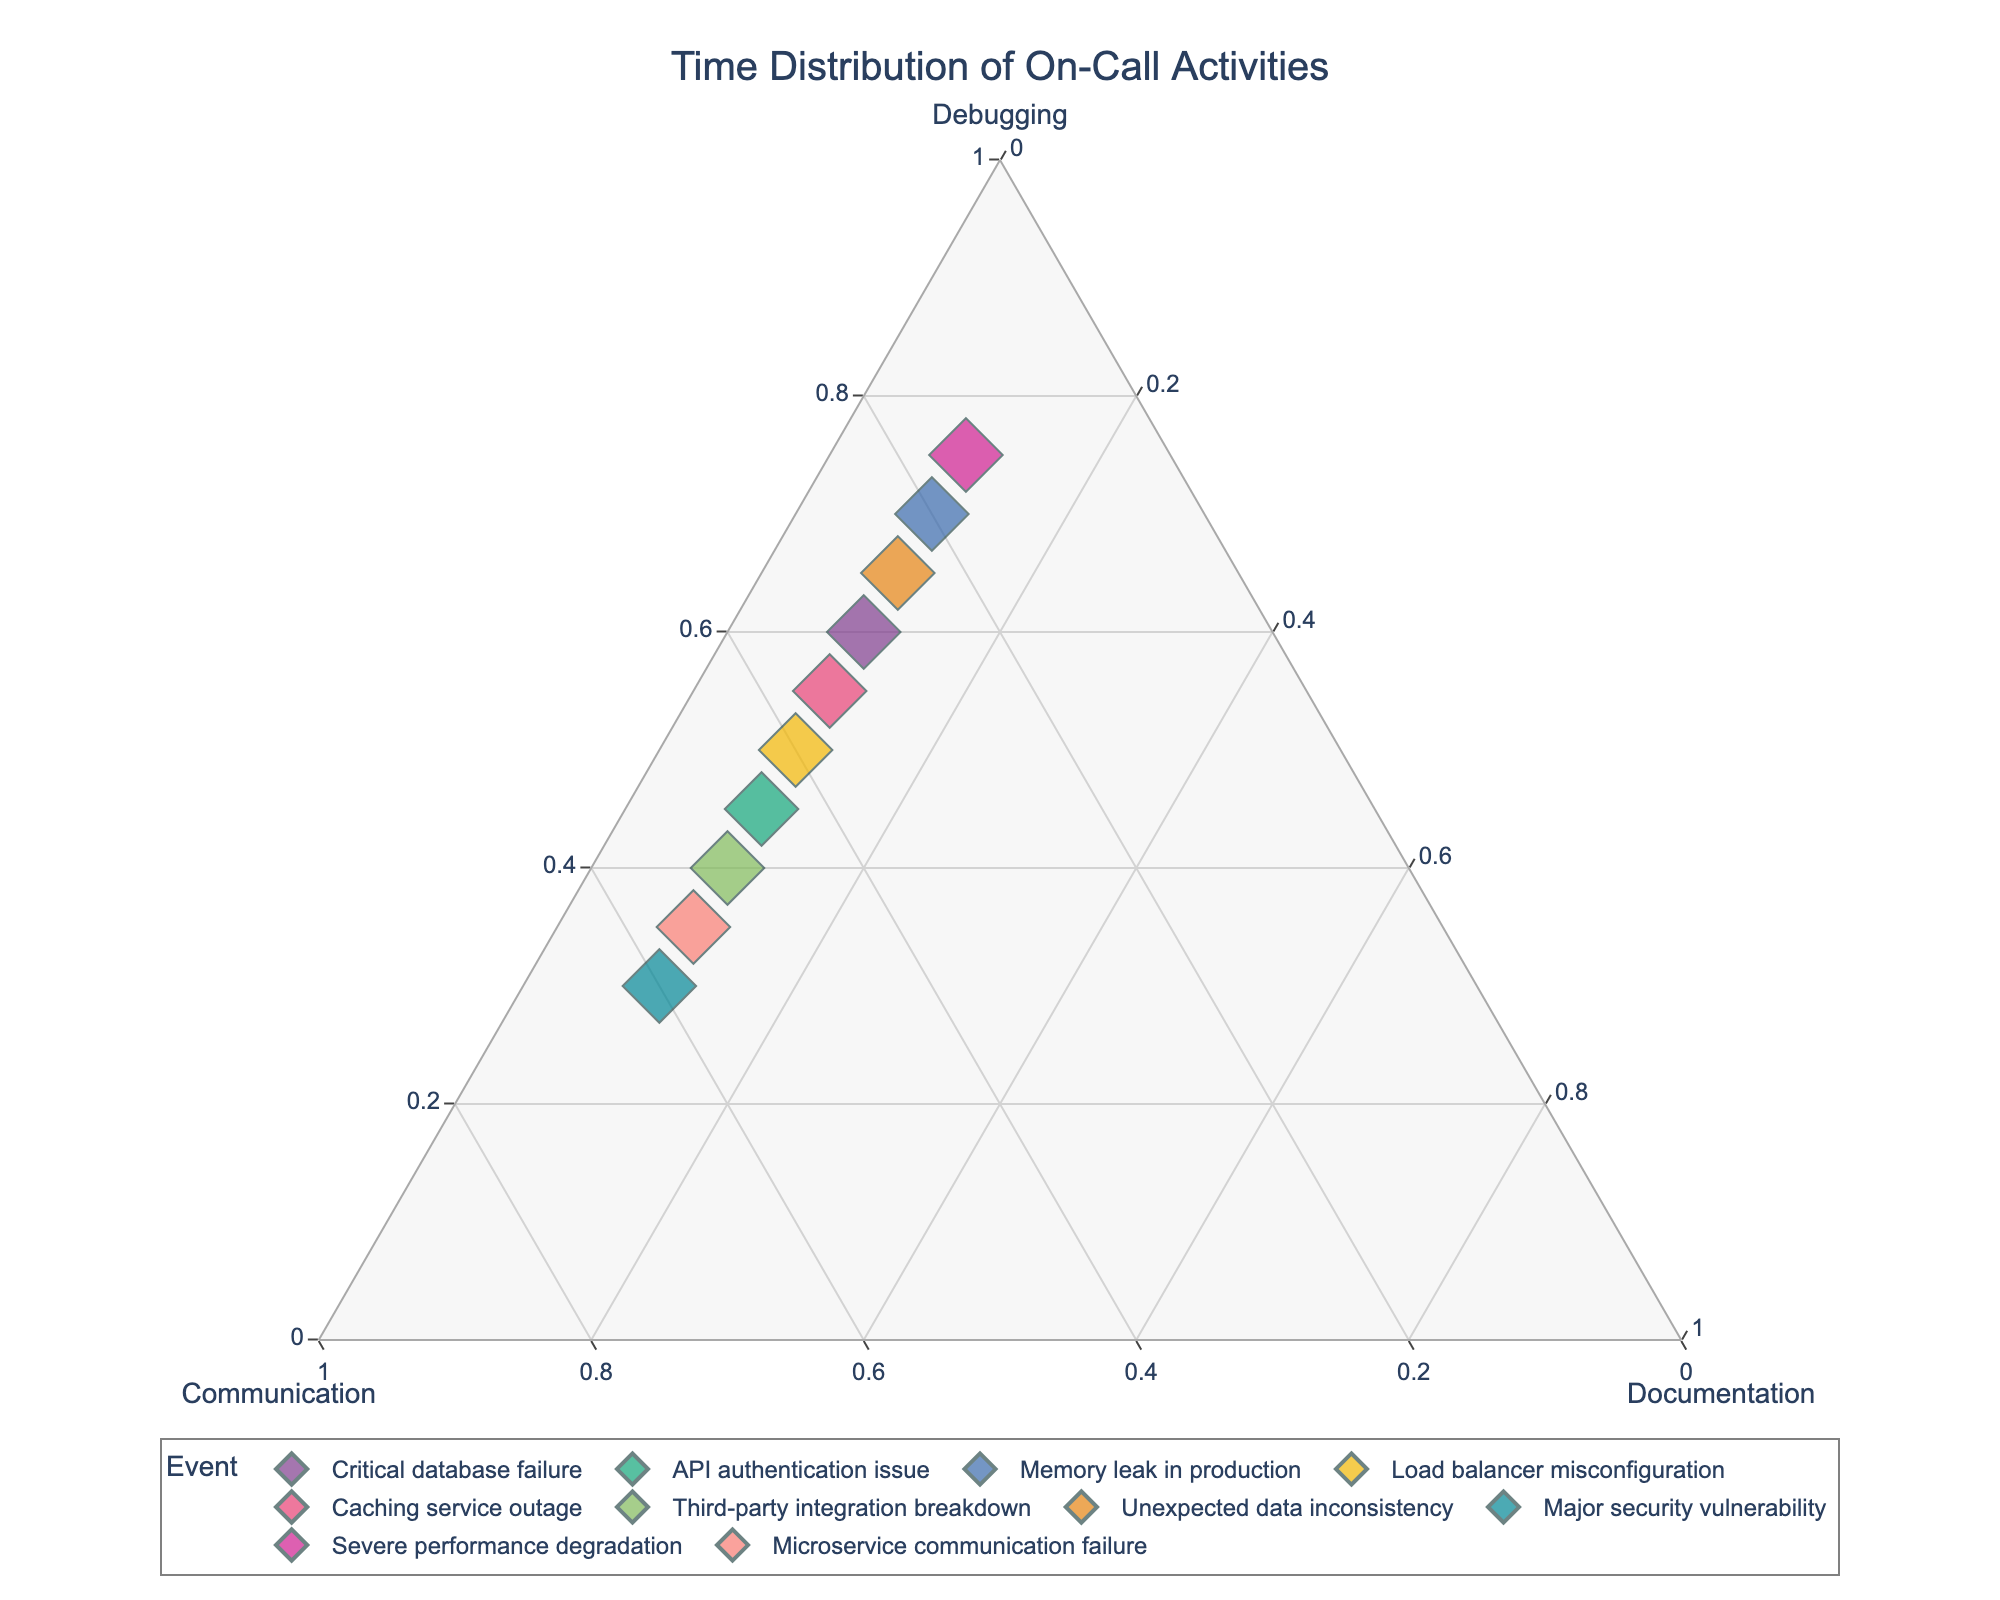What is the title of the plot? The title can be found at the top of the plot, which is centralized.
Answer: Time Distribution of On-Call Activities How many data points are there in the plot? The plot contains one data point per unique event listed in the data. Simply counting the events, you will find 10 data points.
Answer: 10 Which event has the highest percentage dedicated to debugging? By looking at the points plotted on the ternary plot, the event that is closest to the “Debugging” corner is identified. From the data, "Severe performance degradation" has 75% debugging time.
Answer: Severe performance degradation Which event has the highest percentage dedicated to communication? Check the plot for the data point closest to the “Communication” corner. The event "Major security vulnerability" has 60% communication time.
Answer: Major security vulnerability Are there any events with equal percentages of debugging and communication? Find the points where the axes for debugging and communication intersect at the same percentage. From the data, "API authentication issue" has 45% debugging and 45% communication.
Answer: API authentication issue What event has the smallest percentage dedicated to communication? Identify the point closest to the "Debugging" and "Documentation" line, which denotes a lower "Communication" percentage. "Severe performance degradation" has 15% communication time.
Answer: Severe performance degradation What is the median percentage dedicated to documentation across all events? List the documentation percentages {10, 10, 10, 10, 10, 10, 10, 10, 10, 10}, and find the middle value(s). Since all values are the same, the median is 10%.
Answer: 10% Between the events "Critical database failure" and "Memory leak in production," which has a higher percentage of communication? Locate the points for both events on the plot and compare their positions relative to the "Communication" corner. "Critical database failure" has 30% communication, while "Memory leak in production" has 20%.
Answer: Critical database failure What is the average percentage of debugging for the events in the plot? Sum the debugging percentages {60, 45, 70, 50, 55, 40, 65, 30, 75, 35} which equals 525, then divide by the number of events, which is 10. Therefore, 525/10 = 52.5.
Answer: 52.5% Which events have equal percentages dedicated to documentation? From the data, every event is shown to have 10% dedicated to documentation. Hence, all events have equal documentation percentages.
Answer: All events 